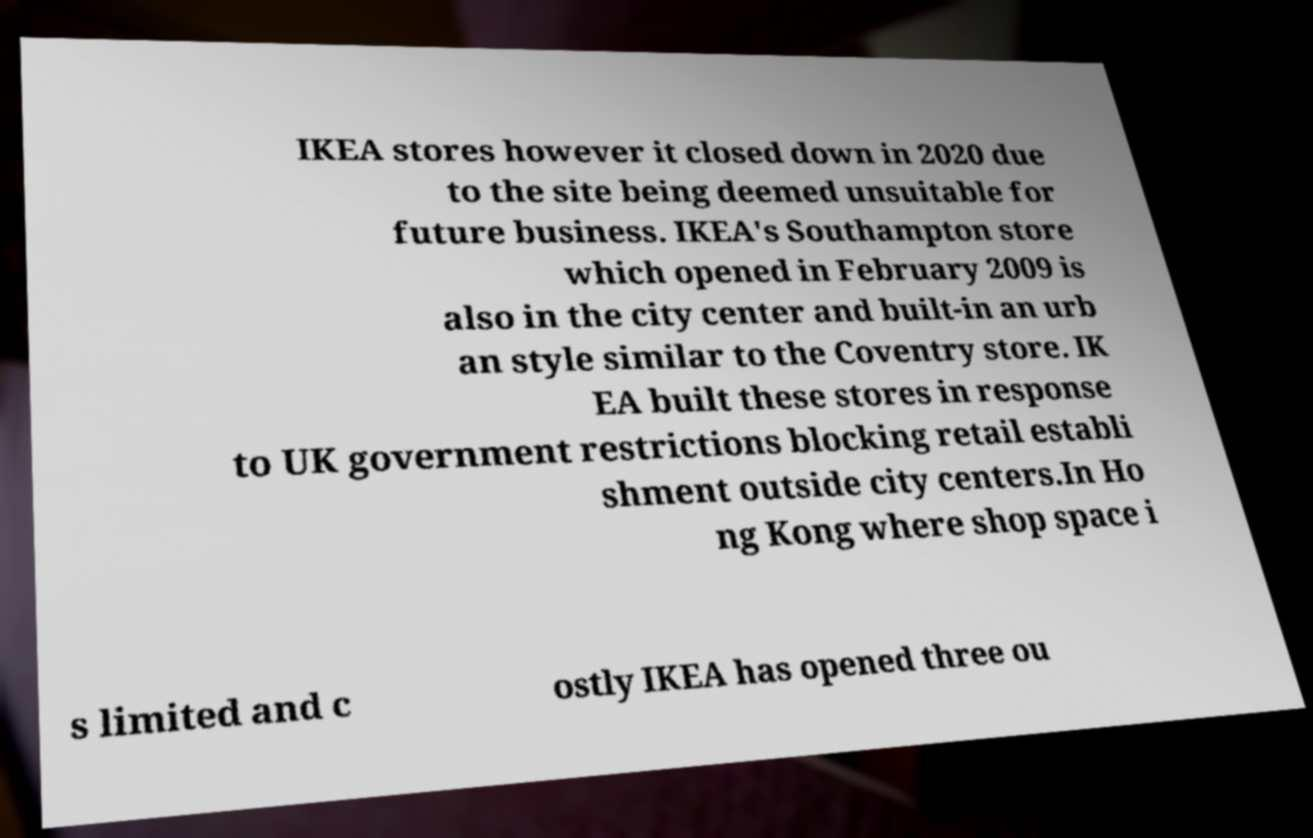Could you assist in decoding the text presented in this image and type it out clearly? IKEA stores however it closed down in 2020 due to the site being deemed unsuitable for future business. IKEA's Southampton store which opened in February 2009 is also in the city center and built-in an urb an style similar to the Coventry store. IK EA built these stores in response to UK government restrictions blocking retail establi shment outside city centers.In Ho ng Kong where shop space i s limited and c ostly IKEA has opened three ou 